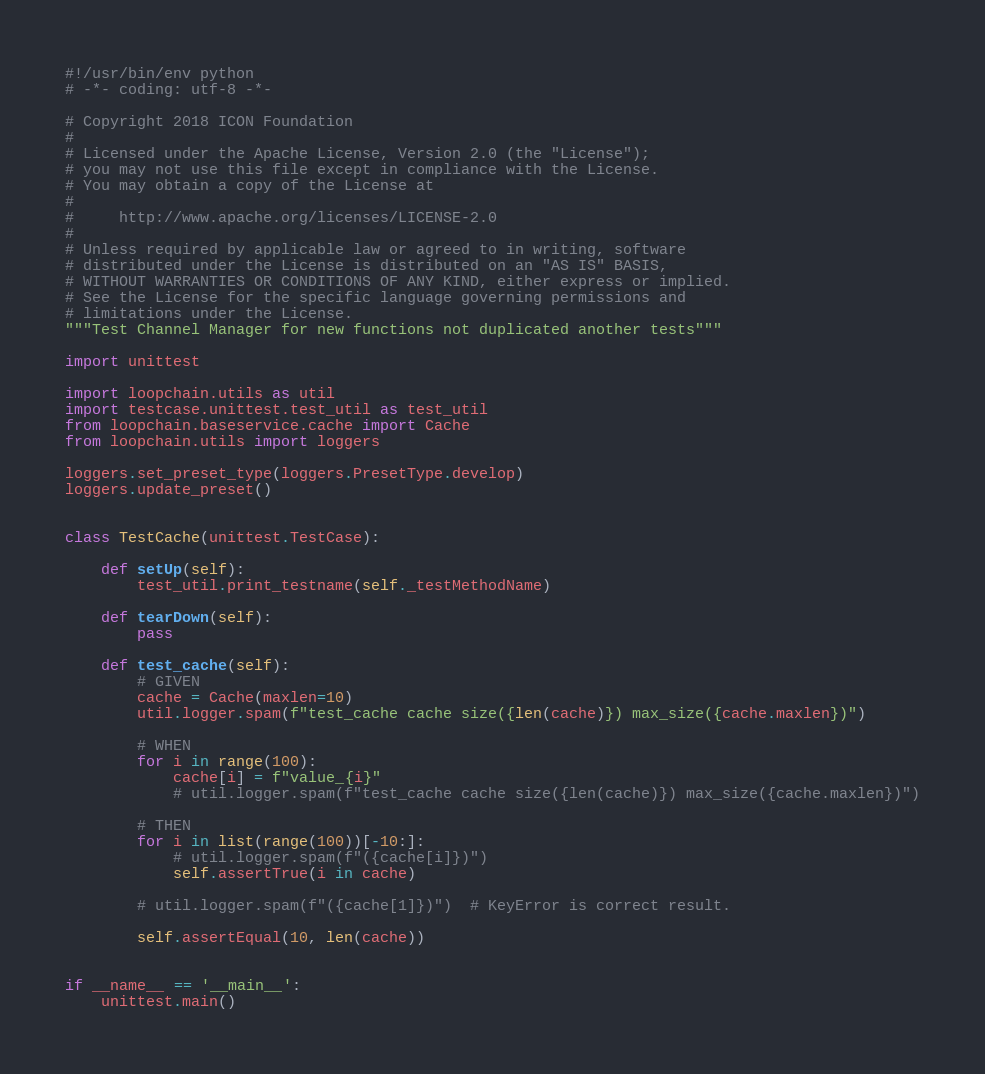Convert code to text. <code><loc_0><loc_0><loc_500><loc_500><_Python_>#!/usr/bin/env python
# -*- coding: utf-8 -*-

# Copyright 2018 ICON Foundation
#
# Licensed under the Apache License, Version 2.0 (the "License");
# you may not use this file except in compliance with the License.
# You may obtain a copy of the License at
#
#     http://www.apache.org/licenses/LICENSE-2.0
#
# Unless required by applicable law or agreed to in writing, software
# distributed under the License is distributed on an "AS IS" BASIS,
# WITHOUT WARRANTIES OR CONDITIONS OF ANY KIND, either express or implied.
# See the License for the specific language governing permissions and
# limitations under the License.
"""Test Channel Manager for new functions not duplicated another tests"""

import unittest

import loopchain.utils as util
import testcase.unittest.test_util as test_util
from loopchain.baseservice.cache import Cache
from loopchain.utils import loggers

loggers.set_preset_type(loggers.PresetType.develop)
loggers.update_preset()


class TestCache(unittest.TestCase):

    def setUp(self):
        test_util.print_testname(self._testMethodName)

    def tearDown(self):
        pass

    def test_cache(self):
        # GIVEN
        cache = Cache(maxlen=10)
        util.logger.spam(f"test_cache cache size({len(cache)}) max_size({cache.maxlen})")

        # WHEN
        for i in range(100):
            cache[i] = f"value_{i}"
            # util.logger.spam(f"test_cache cache size({len(cache)}) max_size({cache.maxlen})")

        # THEN
        for i in list(range(100))[-10:]:
            # util.logger.spam(f"({cache[i]})")
            self.assertTrue(i in cache)

        # util.logger.spam(f"({cache[1]})")  # KeyError is correct result.

        self.assertEqual(10, len(cache))


if __name__ == '__main__':
    unittest.main()
</code> 